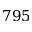Convert formula to latex. <formula><loc_0><loc_0><loc_500><loc_500>7 9 5</formula> 